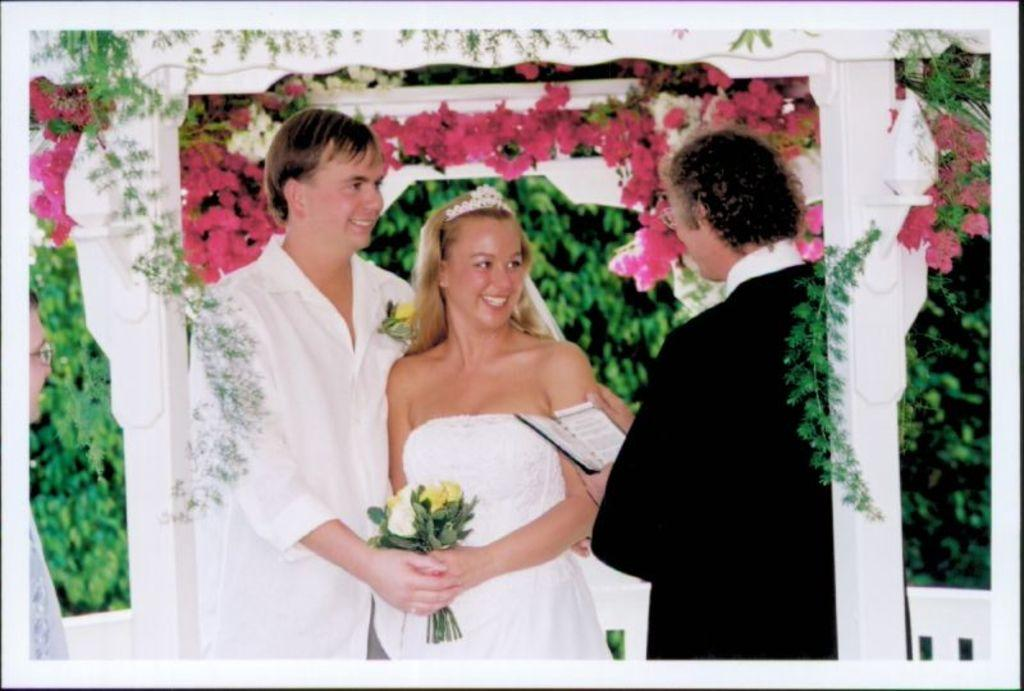What are the persons holding in the image? The persons are holding bouquets and books in the image. What can be seen in the background of the image? There are flowers and trees in the background of the image. Where is the person located in the image? There is a person on the left side of the image. What type of glass is being used to drink water in the image? There is no glass or water present in the image. What season is depicted in the image? The provided facts do not mention any specific season, so it cannot be determined from the image. 